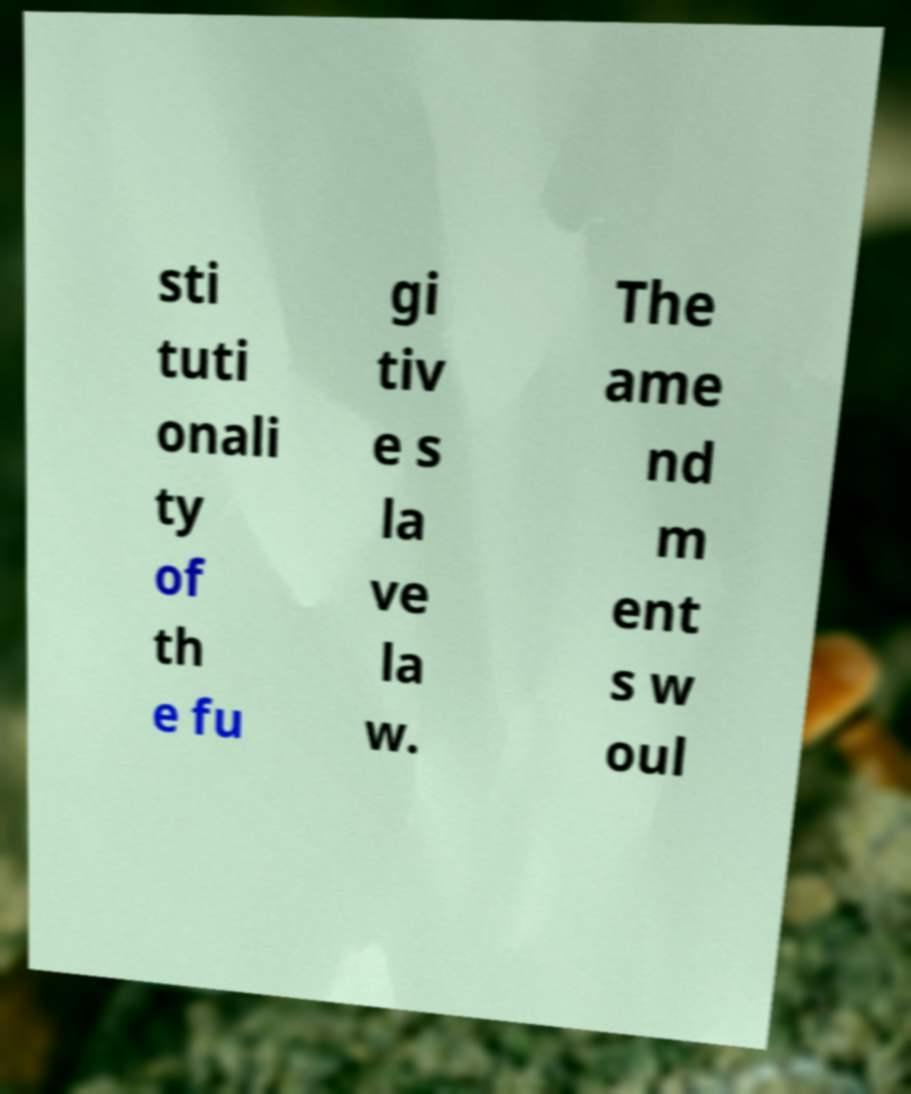There's text embedded in this image that I need extracted. Can you transcribe it verbatim? sti tuti onali ty of th e fu gi tiv e s la ve la w. The ame nd m ent s w oul 